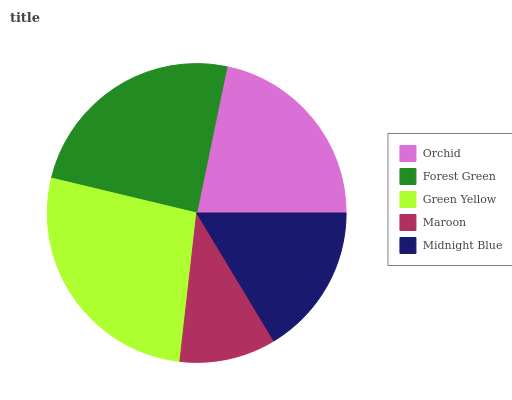Is Maroon the minimum?
Answer yes or no. Yes. Is Green Yellow the maximum?
Answer yes or no. Yes. Is Forest Green the minimum?
Answer yes or no. No. Is Forest Green the maximum?
Answer yes or no. No. Is Forest Green greater than Orchid?
Answer yes or no. Yes. Is Orchid less than Forest Green?
Answer yes or no. Yes. Is Orchid greater than Forest Green?
Answer yes or no. No. Is Forest Green less than Orchid?
Answer yes or no. No. Is Orchid the high median?
Answer yes or no. Yes. Is Orchid the low median?
Answer yes or no. Yes. Is Green Yellow the high median?
Answer yes or no. No. Is Forest Green the low median?
Answer yes or no. No. 